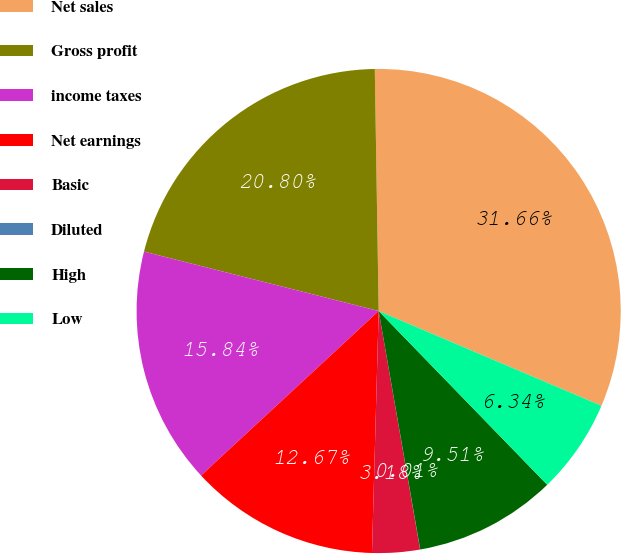<chart> <loc_0><loc_0><loc_500><loc_500><pie_chart><fcel>Net sales<fcel>Gross profit<fcel>income taxes<fcel>Net earnings<fcel>Basic<fcel>Diluted<fcel>High<fcel>Low<nl><fcel>31.66%<fcel>20.8%<fcel>15.84%<fcel>12.67%<fcel>3.18%<fcel>0.01%<fcel>9.51%<fcel>6.34%<nl></chart> 